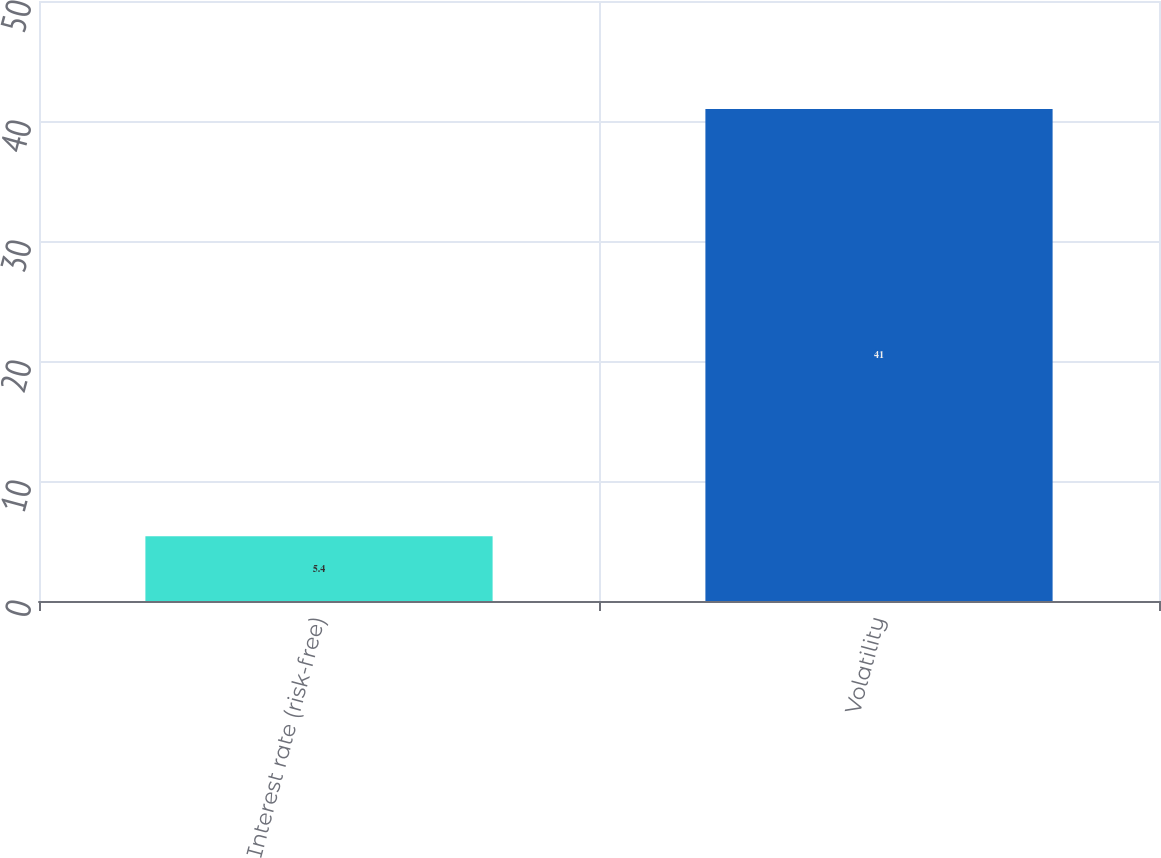<chart> <loc_0><loc_0><loc_500><loc_500><bar_chart><fcel>Interest rate (risk-free)<fcel>Volatility<nl><fcel>5.4<fcel>41<nl></chart> 